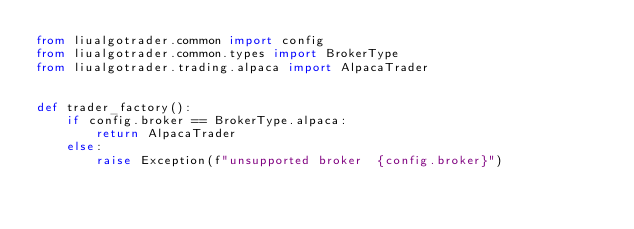Convert code to text. <code><loc_0><loc_0><loc_500><loc_500><_Python_>from liualgotrader.common import config
from liualgotrader.common.types import BrokerType
from liualgotrader.trading.alpaca import AlpacaTrader


def trader_factory():
    if config.broker == BrokerType.alpaca:
        return AlpacaTrader
    else:
        raise Exception(f"unsupported broker  {config.broker}")
</code> 